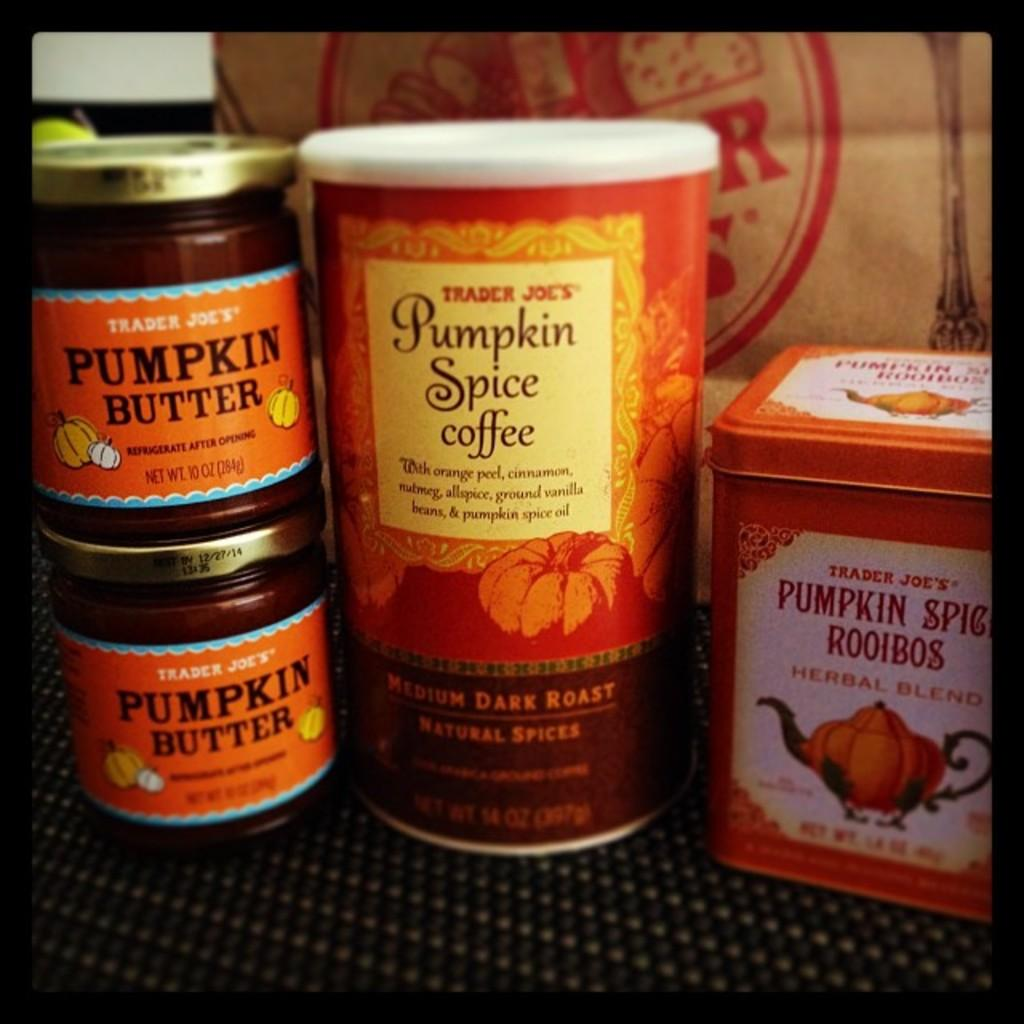<image>
Create a compact narrative representing the image presented. Several items involving pumpkin spice sit stacked on a counter. 